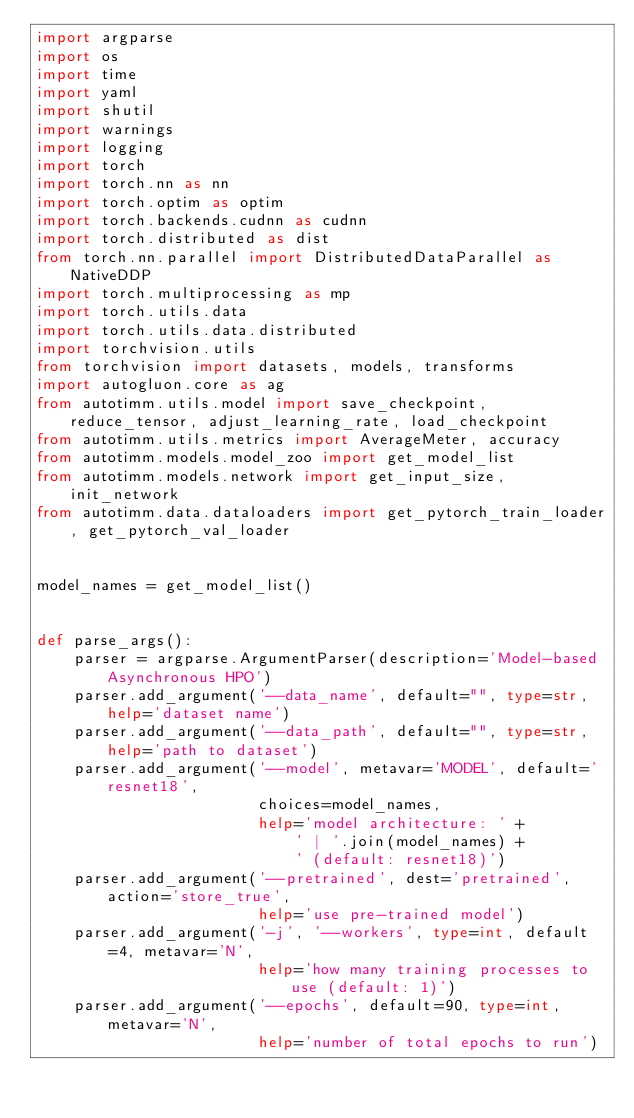<code> <loc_0><loc_0><loc_500><loc_500><_Python_>import argparse
import os
import time
import yaml
import shutil
import warnings
import logging
import torch
import torch.nn as nn
import torch.optim as optim
import torch.backends.cudnn as cudnn
import torch.distributed as dist
from torch.nn.parallel import DistributedDataParallel as NativeDDP
import torch.multiprocessing as mp
import torch.utils.data
import torch.utils.data.distributed
import torchvision.utils
from torchvision import datasets, models, transforms
import autogluon.core as ag
from autotimm.utils.model import save_checkpoint, reduce_tensor, adjust_learning_rate, load_checkpoint
from autotimm.utils.metrics import AverageMeter, accuracy
from autotimm.models.model_zoo import get_model_list
from autotimm.models.network import get_input_size, init_network
from autotimm.data.dataloaders import get_pytorch_train_loader, get_pytorch_val_loader


model_names = get_model_list()


def parse_args():
    parser = argparse.ArgumentParser(description='Model-based Asynchronous HPO')
    parser.add_argument('--data_name', default="", type=str, help='dataset name')
    parser.add_argument('--data_path', default="", type=str, help='path to dataset')
    parser.add_argument('--model', metavar='MODEL', default='resnet18',
                        choices=model_names,
                        help='model architecture: ' +
                            ' | '.join(model_names) +
                            ' (default: resnet18)')
    parser.add_argument('--pretrained', dest='pretrained', action='store_true',
                        help='use pre-trained model')
    parser.add_argument('-j', '--workers', type=int, default=4, metavar='N',
                        help='how many training processes to use (default: 1)')
    parser.add_argument('--epochs', default=90, type=int, metavar='N',
                        help='number of total epochs to run')</code> 